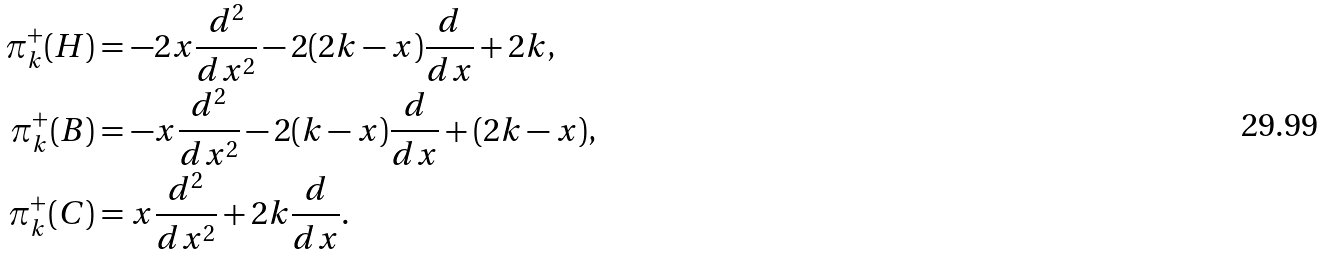Convert formula to latex. <formula><loc_0><loc_0><loc_500><loc_500>\pi ^ { + } _ { k } ( H ) & = - 2 x \frac { d ^ { 2 } } { d x ^ { 2 } } - 2 ( 2 k - x ) \frac { d } { d x } + 2 k , \\ \pi ^ { + } _ { k } ( B ) & = - x \frac { d ^ { 2 } } { d x ^ { 2 } } - 2 ( k - x ) \frac { d } { d x } + ( 2 k - x ) , \\ \pi ^ { + } _ { k } ( C ) & = x \frac { d ^ { 2 } } { d x ^ { 2 } } + 2 k \frac { d } { d x } .</formula> 